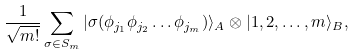Convert formula to latex. <formula><loc_0><loc_0><loc_500><loc_500>\frac { 1 } { \sqrt { m ! } } \sum _ { \sigma \in S _ { m } } | \sigma ( \phi _ { j _ { 1 } } \phi _ { j _ { 2 } } \dots \phi _ { j _ { m } } ) \rangle _ { A } \otimes | 1 , 2 , \dots , m \rangle _ { B } ,</formula> 